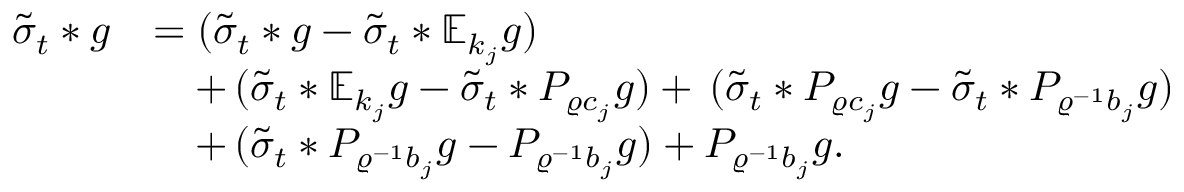<formula> <loc_0><loc_0><loc_500><loc_500>\begin{array} { r l } { \tilde { \sigma } _ { t } \ast g } & { = ( \tilde { \sigma } _ { t } \ast g - \tilde { \sigma } _ { t } \ast \mathbb { E } _ { k _ { j } } g ) } \\ & { \quad + \, ( \tilde { \sigma } _ { t } \ast \mathbb { E } _ { k _ { j } } g - \tilde { \sigma } _ { t } \ast P _ { \varrho c _ { j } } g ) + \, ( \tilde { \sigma } _ { t } \ast P _ { \varrho c _ { j } } g - \tilde { \sigma } _ { t } \ast P _ { \varrho ^ { - 1 } b _ { j } } g ) } \\ & { \quad + \, ( \tilde { \sigma } _ { t } \ast P _ { \varrho ^ { - 1 } b _ { j } } g - P _ { \varrho ^ { - 1 } b _ { j } } g ) + P _ { \varrho ^ { - 1 } b _ { j } } g . } \end{array}</formula> 